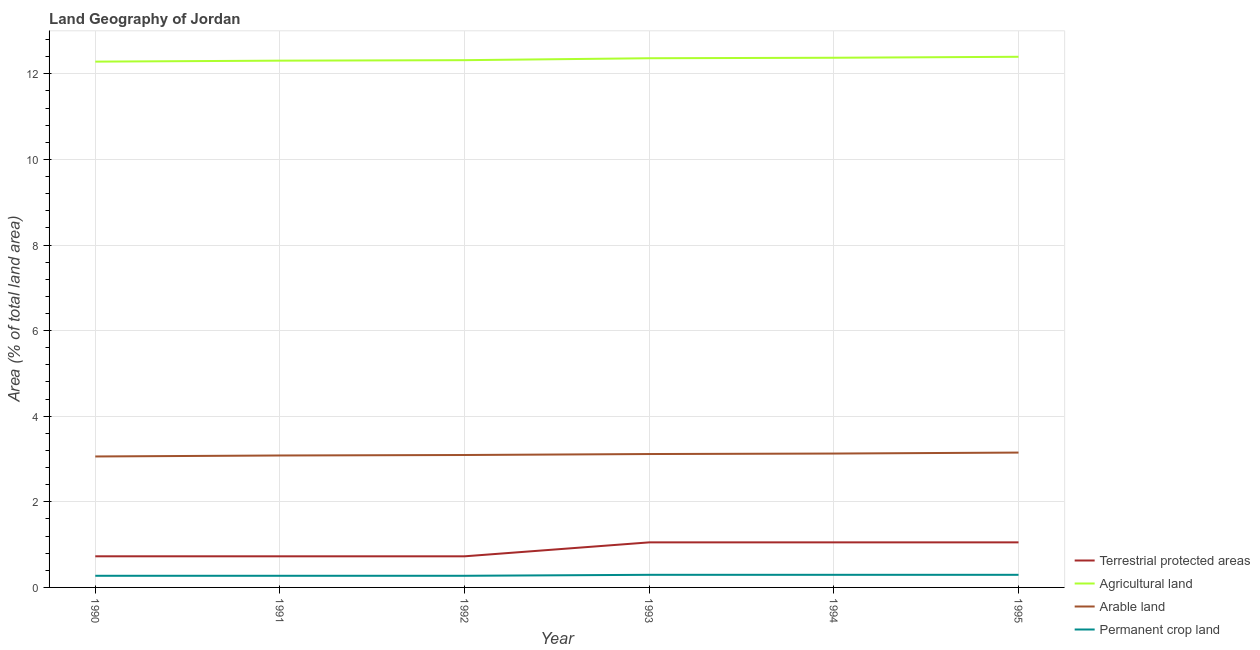What is the percentage of area under agricultural land in 1990?
Your answer should be compact. 12.28. Across all years, what is the maximum percentage of area under agricultural land?
Keep it short and to the point. 12.4. Across all years, what is the minimum percentage of land under terrestrial protection?
Offer a very short reply. 0.73. In which year was the percentage of area under permanent crop land minimum?
Give a very brief answer. 1990. What is the total percentage of area under permanent crop land in the graph?
Give a very brief answer. 1.7. What is the difference between the percentage of area under arable land in 1994 and that in 1995?
Provide a short and direct response. -0.02. What is the difference between the percentage of area under agricultural land in 1992 and the percentage of area under permanent crop land in 1994?
Offer a terse response. 12.02. What is the average percentage of area under agricultural land per year?
Provide a succinct answer. 12.34. In the year 1994, what is the difference between the percentage of area under arable land and percentage of area under permanent crop land?
Offer a very short reply. 2.83. What is the ratio of the percentage of area under arable land in 1994 to that in 1995?
Ensure brevity in your answer.  0.99. Is the difference between the percentage of land under terrestrial protection in 1991 and 1993 greater than the difference between the percentage of area under arable land in 1991 and 1993?
Your answer should be very brief. No. What is the difference between the highest and the second highest percentage of area under permanent crop land?
Provide a succinct answer. 0. What is the difference between the highest and the lowest percentage of area under permanent crop land?
Your answer should be compact. 0.02. In how many years, is the percentage of area under arable land greater than the average percentage of area under arable land taken over all years?
Give a very brief answer. 3. Is it the case that in every year, the sum of the percentage of land under terrestrial protection and percentage of area under permanent crop land is greater than the sum of percentage of area under agricultural land and percentage of area under arable land?
Your response must be concise. No. Is it the case that in every year, the sum of the percentage of land under terrestrial protection and percentage of area under agricultural land is greater than the percentage of area under arable land?
Your answer should be very brief. Yes. Is the percentage of area under agricultural land strictly greater than the percentage of area under permanent crop land over the years?
Your response must be concise. Yes. Is the percentage of area under permanent crop land strictly less than the percentage of area under agricultural land over the years?
Your response must be concise. Yes. How many lines are there?
Your answer should be very brief. 4. How many years are there in the graph?
Provide a short and direct response. 6. What is the difference between two consecutive major ticks on the Y-axis?
Provide a succinct answer. 2. Does the graph contain any zero values?
Your answer should be compact. No. Does the graph contain grids?
Make the answer very short. Yes. How many legend labels are there?
Keep it short and to the point. 4. How are the legend labels stacked?
Make the answer very short. Vertical. What is the title of the graph?
Make the answer very short. Land Geography of Jordan. Does "Quality of public administration" appear as one of the legend labels in the graph?
Your answer should be compact. No. What is the label or title of the Y-axis?
Make the answer very short. Area (% of total land area). What is the Area (% of total land area) in Terrestrial protected areas in 1990?
Keep it short and to the point. 0.73. What is the Area (% of total land area) of Agricultural land in 1990?
Your answer should be compact. 12.28. What is the Area (% of total land area) in Arable land in 1990?
Offer a very short reply. 3.06. What is the Area (% of total land area) of Permanent crop land in 1990?
Offer a very short reply. 0.27. What is the Area (% of total land area) in Terrestrial protected areas in 1991?
Your response must be concise. 0.73. What is the Area (% of total land area) in Agricultural land in 1991?
Make the answer very short. 12.31. What is the Area (% of total land area) of Arable land in 1991?
Offer a very short reply. 3.08. What is the Area (% of total land area) in Permanent crop land in 1991?
Provide a succinct answer. 0.27. What is the Area (% of total land area) in Terrestrial protected areas in 1992?
Provide a succinct answer. 0.73. What is the Area (% of total land area) in Agricultural land in 1992?
Provide a short and direct response. 12.32. What is the Area (% of total land area) in Arable land in 1992?
Your answer should be very brief. 3.09. What is the Area (% of total land area) in Permanent crop land in 1992?
Give a very brief answer. 0.27. What is the Area (% of total land area) of Terrestrial protected areas in 1993?
Offer a very short reply. 1.05. What is the Area (% of total land area) of Agricultural land in 1993?
Keep it short and to the point. 12.36. What is the Area (% of total land area) of Arable land in 1993?
Keep it short and to the point. 3.12. What is the Area (% of total land area) in Permanent crop land in 1993?
Offer a terse response. 0.29. What is the Area (% of total land area) in Terrestrial protected areas in 1994?
Offer a very short reply. 1.05. What is the Area (% of total land area) in Agricultural land in 1994?
Make the answer very short. 12.38. What is the Area (% of total land area) of Arable land in 1994?
Ensure brevity in your answer.  3.13. What is the Area (% of total land area) of Permanent crop land in 1994?
Your response must be concise. 0.29. What is the Area (% of total land area) in Terrestrial protected areas in 1995?
Ensure brevity in your answer.  1.05. What is the Area (% of total land area) of Agricultural land in 1995?
Offer a terse response. 12.4. What is the Area (% of total land area) of Arable land in 1995?
Offer a very short reply. 3.15. What is the Area (% of total land area) of Permanent crop land in 1995?
Offer a very short reply. 0.29. Across all years, what is the maximum Area (% of total land area) in Terrestrial protected areas?
Ensure brevity in your answer.  1.05. Across all years, what is the maximum Area (% of total land area) in Agricultural land?
Offer a very short reply. 12.4. Across all years, what is the maximum Area (% of total land area) in Arable land?
Give a very brief answer. 3.15. Across all years, what is the maximum Area (% of total land area) in Permanent crop land?
Your answer should be very brief. 0.29. Across all years, what is the minimum Area (% of total land area) in Terrestrial protected areas?
Your answer should be compact. 0.73. Across all years, what is the minimum Area (% of total land area) in Agricultural land?
Provide a succinct answer. 12.28. Across all years, what is the minimum Area (% of total land area) in Arable land?
Give a very brief answer. 3.06. Across all years, what is the minimum Area (% of total land area) in Permanent crop land?
Provide a short and direct response. 0.27. What is the total Area (% of total land area) of Terrestrial protected areas in the graph?
Make the answer very short. 5.34. What is the total Area (% of total land area) of Agricultural land in the graph?
Offer a terse response. 74.05. What is the total Area (% of total land area) in Arable land in the graph?
Provide a short and direct response. 18.63. What is the total Area (% of total land area) in Permanent crop land in the graph?
Your response must be concise. 1.7. What is the difference between the Area (% of total land area) of Terrestrial protected areas in 1990 and that in 1991?
Ensure brevity in your answer.  0. What is the difference between the Area (% of total land area) in Agricultural land in 1990 and that in 1991?
Provide a short and direct response. -0.02. What is the difference between the Area (% of total land area) of Arable land in 1990 and that in 1991?
Provide a succinct answer. -0.02. What is the difference between the Area (% of total land area) in Permanent crop land in 1990 and that in 1991?
Your answer should be very brief. 0. What is the difference between the Area (% of total land area) in Terrestrial protected areas in 1990 and that in 1992?
Make the answer very short. 0. What is the difference between the Area (% of total land area) of Agricultural land in 1990 and that in 1992?
Provide a short and direct response. -0.03. What is the difference between the Area (% of total land area) of Arable land in 1990 and that in 1992?
Your answer should be very brief. -0.03. What is the difference between the Area (% of total land area) of Permanent crop land in 1990 and that in 1992?
Offer a very short reply. 0. What is the difference between the Area (% of total land area) in Terrestrial protected areas in 1990 and that in 1993?
Give a very brief answer. -0.33. What is the difference between the Area (% of total land area) of Agricultural land in 1990 and that in 1993?
Provide a succinct answer. -0.08. What is the difference between the Area (% of total land area) in Arable land in 1990 and that in 1993?
Keep it short and to the point. -0.06. What is the difference between the Area (% of total land area) of Permanent crop land in 1990 and that in 1993?
Make the answer very short. -0.02. What is the difference between the Area (% of total land area) in Terrestrial protected areas in 1990 and that in 1994?
Keep it short and to the point. -0.33. What is the difference between the Area (% of total land area) of Agricultural land in 1990 and that in 1994?
Provide a succinct answer. -0.09. What is the difference between the Area (% of total land area) of Arable land in 1990 and that in 1994?
Provide a succinct answer. -0.07. What is the difference between the Area (% of total land area) of Permanent crop land in 1990 and that in 1994?
Your answer should be compact. -0.02. What is the difference between the Area (% of total land area) of Terrestrial protected areas in 1990 and that in 1995?
Give a very brief answer. -0.33. What is the difference between the Area (% of total land area) of Agricultural land in 1990 and that in 1995?
Make the answer very short. -0.11. What is the difference between the Area (% of total land area) in Arable land in 1990 and that in 1995?
Provide a succinct answer. -0.09. What is the difference between the Area (% of total land area) of Permanent crop land in 1990 and that in 1995?
Give a very brief answer. -0.02. What is the difference between the Area (% of total land area) of Terrestrial protected areas in 1991 and that in 1992?
Make the answer very short. 0. What is the difference between the Area (% of total land area) in Agricultural land in 1991 and that in 1992?
Offer a terse response. -0.01. What is the difference between the Area (% of total land area) in Arable land in 1991 and that in 1992?
Make the answer very short. -0.01. What is the difference between the Area (% of total land area) in Terrestrial protected areas in 1991 and that in 1993?
Offer a very short reply. -0.33. What is the difference between the Area (% of total land area) in Agricultural land in 1991 and that in 1993?
Give a very brief answer. -0.06. What is the difference between the Area (% of total land area) of Arable land in 1991 and that in 1993?
Provide a succinct answer. -0.03. What is the difference between the Area (% of total land area) in Permanent crop land in 1991 and that in 1993?
Provide a short and direct response. -0.02. What is the difference between the Area (% of total land area) in Terrestrial protected areas in 1991 and that in 1994?
Make the answer very short. -0.33. What is the difference between the Area (% of total land area) of Agricultural land in 1991 and that in 1994?
Ensure brevity in your answer.  -0.07. What is the difference between the Area (% of total land area) of Arable land in 1991 and that in 1994?
Ensure brevity in your answer.  -0.05. What is the difference between the Area (% of total land area) of Permanent crop land in 1991 and that in 1994?
Keep it short and to the point. -0.02. What is the difference between the Area (% of total land area) in Terrestrial protected areas in 1991 and that in 1995?
Your response must be concise. -0.33. What is the difference between the Area (% of total land area) of Agricultural land in 1991 and that in 1995?
Ensure brevity in your answer.  -0.09. What is the difference between the Area (% of total land area) of Arable land in 1991 and that in 1995?
Your answer should be compact. -0.07. What is the difference between the Area (% of total land area) of Permanent crop land in 1991 and that in 1995?
Give a very brief answer. -0.02. What is the difference between the Area (% of total land area) of Terrestrial protected areas in 1992 and that in 1993?
Offer a very short reply. -0.33. What is the difference between the Area (% of total land area) in Agricultural land in 1992 and that in 1993?
Ensure brevity in your answer.  -0.05. What is the difference between the Area (% of total land area) in Arable land in 1992 and that in 1993?
Your response must be concise. -0.02. What is the difference between the Area (% of total land area) of Permanent crop land in 1992 and that in 1993?
Your response must be concise. -0.02. What is the difference between the Area (% of total land area) of Terrestrial protected areas in 1992 and that in 1994?
Offer a terse response. -0.33. What is the difference between the Area (% of total land area) of Agricultural land in 1992 and that in 1994?
Offer a very short reply. -0.06. What is the difference between the Area (% of total land area) in Arable land in 1992 and that in 1994?
Offer a very short reply. -0.03. What is the difference between the Area (% of total land area) in Permanent crop land in 1992 and that in 1994?
Your answer should be compact. -0.02. What is the difference between the Area (% of total land area) in Terrestrial protected areas in 1992 and that in 1995?
Your response must be concise. -0.33. What is the difference between the Area (% of total land area) of Agricultural land in 1992 and that in 1995?
Keep it short and to the point. -0.08. What is the difference between the Area (% of total land area) in Arable land in 1992 and that in 1995?
Provide a short and direct response. -0.06. What is the difference between the Area (% of total land area) in Permanent crop land in 1992 and that in 1995?
Offer a terse response. -0.02. What is the difference between the Area (% of total land area) in Agricultural land in 1993 and that in 1994?
Your response must be concise. -0.01. What is the difference between the Area (% of total land area) of Arable land in 1993 and that in 1994?
Your answer should be compact. -0.01. What is the difference between the Area (% of total land area) in Permanent crop land in 1993 and that in 1994?
Offer a very short reply. 0. What is the difference between the Area (% of total land area) in Terrestrial protected areas in 1993 and that in 1995?
Keep it short and to the point. 0. What is the difference between the Area (% of total land area) of Agricultural land in 1993 and that in 1995?
Your response must be concise. -0.03. What is the difference between the Area (% of total land area) of Arable land in 1993 and that in 1995?
Your answer should be compact. -0.03. What is the difference between the Area (% of total land area) in Permanent crop land in 1993 and that in 1995?
Give a very brief answer. 0. What is the difference between the Area (% of total land area) of Terrestrial protected areas in 1994 and that in 1995?
Ensure brevity in your answer.  0. What is the difference between the Area (% of total land area) in Agricultural land in 1994 and that in 1995?
Offer a terse response. -0.02. What is the difference between the Area (% of total land area) in Arable land in 1994 and that in 1995?
Your response must be concise. -0.02. What is the difference between the Area (% of total land area) of Permanent crop land in 1994 and that in 1995?
Provide a succinct answer. 0. What is the difference between the Area (% of total land area) in Terrestrial protected areas in 1990 and the Area (% of total land area) in Agricultural land in 1991?
Your answer should be compact. -11.58. What is the difference between the Area (% of total land area) of Terrestrial protected areas in 1990 and the Area (% of total land area) of Arable land in 1991?
Your answer should be very brief. -2.36. What is the difference between the Area (% of total land area) in Terrestrial protected areas in 1990 and the Area (% of total land area) in Permanent crop land in 1991?
Ensure brevity in your answer.  0.46. What is the difference between the Area (% of total land area) of Agricultural land in 1990 and the Area (% of total land area) of Arable land in 1991?
Keep it short and to the point. 9.2. What is the difference between the Area (% of total land area) of Agricultural land in 1990 and the Area (% of total land area) of Permanent crop land in 1991?
Give a very brief answer. 12.01. What is the difference between the Area (% of total land area) of Arable land in 1990 and the Area (% of total land area) of Permanent crop land in 1991?
Your response must be concise. 2.79. What is the difference between the Area (% of total land area) in Terrestrial protected areas in 1990 and the Area (% of total land area) in Agricultural land in 1992?
Provide a succinct answer. -11.59. What is the difference between the Area (% of total land area) of Terrestrial protected areas in 1990 and the Area (% of total land area) of Arable land in 1992?
Ensure brevity in your answer.  -2.37. What is the difference between the Area (% of total land area) of Terrestrial protected areas in 1990 and the Area (% of total land area) of Permanent crop land in 1992?
Ensure brevity in your answer.  0.46. What is the difference between the Area (% of total land area) in Agricultural land in 1990 and the Area (% of total land area) in Arable land in 1992?
Keep it short and to the point. 9.19. What is the difference between the Area (% of total land area) in Agricultural land in 1990 and the Area (% of total land area) in Permanent crop land in 1992?
Provide a short and direct response. 12.01. What is the difference between the Area (% of total land area) of Arable land in 1990 and the Area (% of total land area) of Permanent crop land in 1992?
Ensure brevity in your answer.  2.79. What is the difference between the Area (% of total land area) of Terrestrial protected areas in 1990 and the Area (% of total land area) of Agricultural land in 1993?
Give a very brief answer. -11.64. What is the difference between the Area (% of total land area) of Terrestrial protected areas in 1990 and the Area (% of total land area) of Arable land in 1993?
Offer a terse response. -2.39. What is the difference between the Area (% of total land area) of Terrestrial protected areas in 1990 and the Area (% of total land area) of Permanent crop land in 1993?
Your response must be concise. 0.43. What is the difference between the Area (% of total land area) of Agricultural land in 1990 and the Area (% of total land area) of Arable land in 1993?
Keep it short and to the point. 9.17. What is the difference between the Area (% of total land area) of Agricultural land in 1990 and the Area (% of total land area) of Permanent crop land in 1993?
Offer a very short reply. 11.99. What is the difference between the Area (% of total land area) of Arable land in 1990 and the Area (% of total land area) of Permanent crop land in 1993?
Your response must be concise. 2.77. What is the difference between the Area (% of total land area) of Terrestrial protected areas in 1990 and the Area (% of total land area) of Agricultural land in 1994?
Keep it short and to the point. -11.65. What is the difference between the Area (% of total land area) in Terrestrial protected areas in 1990 and the Area (% of total land area) in Arable land in 1994?
Your response must be concise. -2.4. What is the difference between the Area (% of total land area) of Terrestrial protected areas in 1990 and the Area (% of total land area) of Permanent crop land in 1994?
Provide a succinct answer. 0.43. What is the difference between the Area (% of total land area) in Agricultural land in 1990 and the Area (% of total land area) in Arable land in 1994?
Provide a succinct answer. 9.16. What is the difference between the Area (% of total land area) in Agricultural land in 1990 and the Area (% of total land area) in Permanent crop land in 1994?
Make the answer very short. 11.99. What is the difference between the Area (% of total land area) of Arable land in 1990 and the Area (% of total land area) of Permanent crop land in 1994?
Your response must be concise. 2.77. What is the difference between the Area (% of total land area) in Terrestrial protected areas in 1990 and the Area (% of total land area) in Agricultural land in 1995?
Offer a very short reply. -11.67. What is the difference between the Area (% of total land area) of Terrestrial protected areas in 1990 and the Area (% of total land area) of Arable land in 1995?
Offer a very short reply. -2.42. What is the difference between the Area (% of total land area) of Terrestrial protected areas in 1990 and the Area (% of total land area) of Permanent crop land in 1995?
Make the answer very short. 0.43. What is the difference between the Area (% of total land area) of Agricultural land in 1990 and the Area (% of total land area) of Arable land in 1995?
Provide a succinct answer. 9.13. What is the difference between the Area (% of total land area) in Agricultural land in 1990 and the Area (% of total land area) in Permanent crop land in 1995?
Ensure brevity in your answer.  11.99. What is the difference between the Area (% of total land area) of Arable land in 1990 and the Area (% of total land area) of Permanent crop land in 1995?
Provide a short and direct response. 2.77. What is the difference between the Area (% of total land area) of Terrestrial protected areas in 1991 and the Area (% of total land area) of Agricultural land in 1992?
Your response must be concise. -11.59. What is the difference between the Area (% of total land area) in Terrestrial protected areas in 1991 and the Area (% of total land area) in Arable land in 1992?
Offer a terse response. -2.37. What is the difference between the Area (% of total land area) in Terrestrial protected areas in 1991 and the Area (% of total land area) in Permanent crop land in 1992?
Provide a succinct answer. 0.45. What is the difference between the Area (% of total land area) of Agricultural land in 1991 and the Area (% of total land area) of Arable land in 1992?
Offer a very short reply. 9.21. What is the difference between the Area (% of total land area) in Agricultural land in 1991 and the Area (% of total land area) in Permanent crop land in 1992?
Provide a short and direct response. 12.04. What is the difference between the Area (% of total land area) of Arable land in 1991 and the Area (% of total land area) of Permanent crop land in 1992?
Your answer should be very brief. 2.81. What is the difference between the Area (% of total land area) in Terrestrial protected areas in 1991 and the Area (% of total land area) in Agricultural land in 1993?
Your response must be concise. -11.64. What is the difference between the Area (% of total land area) of Terrestrial protected areas in 1991 and the Area (% of total land area) of Arable land in 1993?
Provide a succinct answer. -2.39. What is the difference between the Area (% of total land area) of Terrestrial protected areas in 1991 and the Area (% of total land area) of Permanent crop land in 1993?
Your response must be concise. 0.43. What is the difference between the Area (% of total land area) of Agricultural land in 1991 and the Area (% of total land area) of Arable land in 1993?
Ensure brevity in your answer.  9.19. What is the difference between the Area (% of total land area) in Agricultural land in 1991 and the Area (% of total land area) in Permanent crop land in 1993?
Ensure brevity in your answer.  12.01. What is the difference between the Area (% of total land area) in Arable land in 1991 and the Area (% of total land area) in Permanent crop land in 1993?
Make the answer very short. 2.79. What is the difference between the Area (% of total land area) of Terrestrial protected areas in 1991 and the Area (% of total land area) of Agricultural land in 1994?
Keep it short and to the point. -11.65. What is the difference between the Area (% of total land area) in Terrestrial protected areas in 1991 and the Area (% of total land area) in Arable land in 1994?
Provide a short and direct response. -2.4. What is the difference between the Area (% of total land area) in Terrestrial protected areas in 1991 and the Area (% of total land area) in Permanent crop land in 1994?
Keep it short and to the point. 0.43. What is the difference between the Area (% of total land area) of Agricultural land in 1991 and the Area (% of total land area) of Arable land in 1994?
Your answer should be very brief. 9.18. What is the difference between the Area (% of total land area) in Agricultural land in 1991 and the Area (% of total land area) in Permanent crop land in 1994?
Your answer should be compact. 12.01. What is the difference between the Area (% of total land area) in Arable land in 1991 and the Area (% of total land area) in Permanent crop land in 1994?
Keep it short and to the point. 2.79. What is the difference between the Area (% of total land area) in Terrestrial protected areas in 1991 and the Area (% of total land area) in Agricultural land in 1995?
Your answer should be compact. -11.67. What is the difference between the Area (% of total land area) of Terrestrial protected areas in 1991 and the Area (% of total land area) of Arable land in 1995?
Provide a short and direct response. -2.42. What is the difference between the Area (% of total land area) in Terrestrial protected areas in 1991 and the Area (% of total land area) in Permanent crop land in 1995?
Provide a succinct answer. 0.43. What is the difference between the Area (% of total land area) in Agricultural land in 1991 and the Area (% of total land area) in Arable land in 1995?
Make the answer very short. 9.16. What is the difference between the Area (% of total land area) of Agricultural land in 1991 and the Area (% of total land area) of Permanent crop land in 1995?
Offer a terse response. 12.01. What is the difference between the Area (% of total land area) in Arable land in 1991 and the Area (% of total land area) in Permanent crop land in 1995?
Your answer should be compact. 2.79. What is the difference between the Area (% of total land area) in Terrestrial protected areas in 1992 and the Area (% of total land area) in Agricultural land in 1993?
Keep it short and to the point. -11.64. What is the difference between the Area (% of total land area) of Terrestrial protected areas in 1992 and the Area (% of total land area) of Arable land in 1993?
Offer a terse response. -2.39. What is the difference between the Area (% of total land area) in Terrestrial protected areas in 1992 and the Area (% of total land area) in Permanent crop land in 1993?
Ensure brevity in your answer.  0.43. What is the difference between the Area (% of total land area) of Agricultural land in 1992 and the Area (% of total land area) of Arable land in 1993?
Offer a very short reply. 9.2. What is the difference between the Area (% of total land area) in Agricultural land in 1992 and the Area (% of total land area) in Permanent crop land in 1993?
Ensure brevity in your answer.  12.02. What is the difference between the Area (% of total land area) of Arable land in 1992 and the Area (% of total land area) of Permanent crop land in 1993?
Your response must be concise. 2.8. What is the difference between the Area (% of total land area) in Terrestrial protected areas in 1992 and the Area (% of total land area) in Agricultural land in 1994?
Your answer should be very brief. -11.65. What is the difference between the Area (% of total land area) of Terrestrial protected areas in 1992 and the Area (% of total land area) of Arable land in 1994?
Provide a succinct answer. -2.4. What is the difference between the Area (% of total land area) of Terrestrial protected areas in 1992 and the Area (% of total land area) of Permanent crop land in 1994?
Your answer should be compact. 0.43. What is the difference between the Area (% of total land area) in Agricultural land in 1992 and the Area (% of total land area) in Arable land in 1994?
Offer a terse response. 9.19. What is the difference between the Area (% of total land area) in Agricultural land in 1992 and the Area (% of total land area) in Permanent crop land in 1994?
Your answer should be compact. 12.02. What is the difference between the Area (% of total land area) of Arable land in 1992 and the Area (% of total land area) of Permanent crop land in 1994?
Ensure brevity in your answer.  2.8. What is the difference between the Area (% of total land area) of Terrestrial protected areas in 1992 and the Area (% of total land area) of Agricultural land in 1995?
Your answer should be compact. -11.67. What is the difference between the Area (% of total land area) of Terrestrial protected areas in 1992 and the Area (% of total land area) of Arable land in 1995?
Give a very brief answer. -2.42. What is the difference between the Area (% of total land area) of Terrestrial protected areas in 1992 and the Area (% of total land area) of Permanent crop land in 1995?
Your answer should be very brief. 0.43. What is the difference between the Area (% of total land area) of Agricultural land in 1992 and the Area (% of total land area) of Arable land in 1995?
Your answer should be compact. 9.17. What is the difference between the Area (% of total land area) of Agricultural land in 1992 and the Area (% of total land area) of Permanent crop land in 1995?
Offer a very short reply. 12.02. What is the difference between the Area (% of total land area) in Arable land in 1992 and the Area (% of total land area) in Permanent crop land in 1995?
Offer a very short reply. 2.8. What is the difference between the Area (% of total land area) of Terrestrial protected areas in 1993 and the Area (% of total land area) of Agricultural land in 1994?
Make the answer very short. -11.32. What is the difference between the Area (% of total land area) of Terrestrial protected areas in 1993 and the Area (% of total land area) of Arable land in 1994?
Offer a terse response. -2.08. What is the difference between the Area (% of total land area) of Terrestrial protected areas in 1993 and the Area (% of total land area) of Permanent crop land in 1994?
Give a very brief answer. 0.76. What is the difference between the Area (% of total land area) of Agricultural land in 1993 and the Area (% of total land area) of Arable land in 1994?
Keep it short and to the point. 9.24. What is the difference between the Area (% of total land area) in Agricultural land in 1993 and the Area (% of total land area) in Permanent crop land in 1994?
Provide a short and direct response. 12.07. What is the difference between the Area (% of total land area) in Arable land in 1993 and the Area (% of total land area) in Permanent crop land in 1994?
Keep it short and to the point. 2.82. What is the difference between the Area (% of total land area) in Terrestrial protected areas in 1993 and the Area (% of total land area) in Agricultural land in 1995?
Make the answer very short. -11.35. What is the difference between the Area (% of total land area) in Terrestrial protected areas in 1993 and the Area (% of total land area) in Arable land in 1995?
Offer a terse response. -2.1. What is the difference between the Area (% of total land area) of Terrestrial protected areas in 1993 and the Area (% of total land area) of Permanent crop land in 1995?
Your answer should be compact. 0.76. What is the difference between the Area (% of total land area) in Agricultural land in 1993 and the Area (% of total land area) in Arable land in 1995?
Offer a very short reply. 9.21. What is the difference between the Area (% of total land area) in Agricultural land in 1993 and the Area (% of total land area) in Permanent crop land in 1995?
Offer a terse response. 12.07. What is the difference between the Area (% of total land area) in Arable land in 1993 and the Area (% of total land area) in Permanent crop land in 1995?
Make the answer very short. 2.82. What is the difference between the Area (% of total land area) of Terrestrial protected areas in 1994 and the Area (% of total land area) of Agricultural land in 1995?
Provide a succinct answer. -11.35. What is the difference between the Area (% of total land area) of Terrestrial protected areas in 1994 and the Area (% of total land area) of Arable land in 1995?
Offer a very short reply. -2.1. What is the difference between the Area (% of total land area) in Terrestrial protected areas in 1994 and the Area (% of total land area) in Permanent crop land in 1995?
Ensure brevity in your answer.  0.76. What is the difference between the Area (% of total land area) of Agricultural land in 1994 and the Area (% of total land area) of Arable land in 1995?
Offer a terse response. 9.22. What is the difference between the Area (% of total land area) in Agricultural land in 1994 and the Area (% of total land area) in Permanent crop land in 1995?
Your response must be concise. 12.08. What is the difference between the Area (% of total land area) of Arable land in 1994 and the Area (% of total land area) of Permanent crop land in 1995?
Your response must be concise. 2.83. What is the average Area (% of total land area) in Terrestrial protected areas per year?
Keep it short and to the point. 0.89. What is the average Area (% of total land area) in Agricultural land per year?
Your answer should be compact. 12.34. What is the average Area (% of total land area) in Arable land per year?
Provide a short and direct response. 3.11. What is the average Area (% of total land area) in Permanent crop land per year?
Your answer should be compact. 0.28. In the year 1990, what is the difference between the Area (% of total land area) in Terrestrial protected areas and Area (% of total land area) in Agricultural land?
Make the answer very short. -11.56. In the year 1990, what is the difference between the Area (% of total land area) of Terrestrial protected areas and Area (% of total land area) of Arable land?
Your answer should be very brief. -2.33. In the year 1990, what is the difference between the Area (% of total land area) in Terrestrial protected areas and Area (% of total land area) in Permanent crop land?
Keep it short and to the point. 0.46. In the year 1990, what is the difference between the Area (% of total land area) in Agricultural land and Area (% of total land area) in Arable land?
Give a very brief answer. 9.22. In the year 1990, what is the difference between the Area (% of total land area) of Agricultural land and Area (% of total land area) of Permanent crop land?
Offer a terse response. 12.01. In the year 1990, what is the difference between the Area (% of total land area) of Arable land and Area (% of total land area) of Permanent crop land?
Your answer should be very brief. 2.79. In the year 1991, what is the difference between the Area (% of total land area) of Terrestrial protected areas and Area (% of total land area) of Agricultural land?
Provide a succinct answer. -11.58. In the year 1991, what is the difference between the Area (% of total land area) of Terrestrial protected areas and Area (% of total land area) of Arable land?
Offer a terse response. -2.36. In the year 1991, what is the difference between the Area (% of total land area) of Terrestrial protected areas and Area (% of total land area) of Permanent crop land?
Make the answer very short. 0.45. In the year 1991, what is the difference between the Area (% of total land area) of Agricultural land and Area (% of total land area) of Arable land?
Provide a short and direct response. 9.22. In the year 1991, what is the difference between the Area (% of total land area) in Agricultural land and Area (% of total land area) in Permanent crop land?
Offer a very short reply. 12.04. In the year 1991, what is the difference between the Area (% of total land area) of Arable land and Area (% of total land area) of Permanent crop land?
Provide a short and direct response. 2.81. In the year 1992, what is the difference between the Area (% of total land area) in Terrestrial protected areas and Area (% of total land area) in Agricultural land?
Offer a terse response. -11.59. In the year 1992, what is the difference between the Area (% of total land area) of Terrestrial protected areas and Area (% of total land area) of Arable land?
Your response must be concise. -2.37. In the year 1992, what is the difference between the Area (% of total land area) in Terrestrial protected areas and Area (% of total land area) in Permanent crop land?
Provide a short and direct response. 0.45. In the year 1992, what is the difference between the Area (% of total land area) in Agricultural land and Area (% of total land area) in Arable land?
Your response must be concise. 9.22. In the year 1992, what is the difference between the Area (% of total land area) of Agricultural land and Area (% of total land area) of Permanent crop land?
Your answer should be very brief. 12.05. In the year 1992, what is the difference between the Area (% of total land area) in Arable land and Area (% of total land area) in Permanent crop land?
Your answer should be very brief. 2.82. In the year 1993, what is the difference between the Area (% of total land area) of Terrestrial protected areas and Area (% of total land area) of Agricultural land?
Keep it short and to the point. -11.31. In the year 1993, what is the difference between the Area (% of total land area) in Terrestrial protected areas and Area (% of total land area) in Arable land?
Make the answer very short. -2.06. In the year 1993, what is the difference between the Area (% of total land area) of Terrestrial protected areas and Area (% of total land area) of Permanent crop land?
Provide a succinct answer. 0.76. In the year 1993, what is the difference between the Area (% of total land area) in Agricultural land and Area (% of total land area) in Arable land?
Your response must be concise. 9.25. In the year 1993, what is the difference between the Area (% of total land area) in Agricultural land and Area (% of total land area) in Permanent crop land?
Offer a terse response. 12.07. In the year 1993, what is the difference between the Area (% of total land area) in Arable land and Area (% of total land area) in Permanent crop land?
Your response must be concise. 2.82. In the year 1994, what is the difference between the Area (% of total land area) in Terrestrial protected areas and Area (% of total land area) in Agricultural land?
Ensure brevity in your answer.  -11.32. In the year 1994, what is the difference between the Area (% of total land area) of Terrestrial protected areas and Area (% of total land area) of Arable land?
Keep it short and to the point. -2.08. In the year 1994, what is the difference between the Area (% of total land area) in Terrestrial protected areas and Area (% of total land area) in Permanent crop land?
Give a very brief answer. 0.76. In the year 1994, what is the difference between the Area (% of total land area) of Agricultural land and Area (% of total land area) of Arable land?
Provide a short and direct response. 9.25. In the year 1994, what is the difference between the Area (% of total land area) of Agricultural land and Area (% of total land area) of Permanent crop land?
Offer a very short reply. 12.08. In the year 1994, what is the difference between the Area (% of total land area) of Arable land and Area (% of total land area) of Permanent crop land?
Your response must be concise. 2.83. In the year 1995, what is the difference between the Area (% of total land area) of Terrestrial protected areas and Area (% of total land area) of Agricultural land?
Give a very brief answer. -11.35. In the year 1995, what is the difference between the Area (% of total land area) of Terrestrial protected areas and Area (% of total land area) of Arable land?
Give a very brief answer. -2.1. In the year 1995, what is the difference between the Area (% of total land area) in Terrestrial protected areas and Area (% of total land area) in Permanent crop land?
Provide a short and direct response. 0.76. In the year 1995, what is the difference between the Area (% of total land area) in Agricultural land and Area (% of total land area) in Arable land?
Keep it short and to the point. 9.25. In the year 1995, what is the difference between the Area (% of total land area) of Agricultural land and Area (% of total land area) of Permanent crop land?
Provide a succinct answer. 12.1. In the year 1995, what is the difference between the Area (% of total land area) in Arable land and Area (% of total land area) in Permanent crop land?
Offer a terse response. 2.86. What is the ratio of the Area (% of total land area) in Terrestrial protected areas in 1990 to that in 1991?
Keep it short and to the point. 1. What is the ratio of the Area (% of total land area) in Agricultural land in 1990 to that in 1991?
Ensure brevity in your answer.  1. What is the ratio of the Area (% of total land area) in Arable land in 1990 to that in 1991?
Your response must be concise. 0.99. What is the ratio of the Area (% of total land area) of Agricultural land in 1990 to that in 1992?
Your answer should be very brief. 1. What is the ratio of the Area (% of total land area) in Permanent crop land in 1990 to that in 1992?
Keep it short and to the point. 1. What is the ratio of the Area (% of total land area) of Terrestrial protected areas in 1990 to that in 1993?
Your answer should be very brief. 0.69. What is the ratio of the Area (% of total land area) of Agricultural land in 1990 to that in 1993?
Offer a very short reply. 0.99. What is the ratio of the Area (% of total land area) of Arable land in 1990 to that in 1993?
Your answer should be very brief. 0.98. What is the ratio of the Area (% of total land area) of Permanent crop land in 1990 to that in 1993?
Keep it short and to the point. 0.92. What is the ratio of the Area (% of total land area) in Terrestrial protected areas in 1990 to that in 1994?
Your response must be concise. 0.69. What is the ratio of the Area (% of total land area) of Agricultural land in 1990 to that in 1994?
Provide a succinct answer. 0.99. What is the ratio of the Area (% of total land area) of Arable land in 1990 to that in 1994?
Your answer should be very brief. 0.98. What is the ratio of the Area (% of total land area) in Terrestrial protected areas in 1990 to that in 1995?
Make the answer very short. 0.69. What is the ratio of the Area (% of total land area) in Agricultural land in 1990 to that in 1995?
Offer a terse response. 0.99. What is the ratio of the Area (% of total land area) in Arable land in 1990 to that in 1995?
Offer a terse response. 0.97. What is the ratio of the Area (% of total land area) in Terrestrial protected areas in 1991 to that in 1992?
Ensure brevity in your answer.  1. What is the ratio of the Area (% of total land area) of Arable land in 1991 to that in 1992?
Provide a short and direct response. 1. What is the ratio of the Area (% of total land area) of Terrestrial protected areas in 1991 to that in 1993?
Keep it short and to the point. 0.69. What is the ratio of the Area (% of total land area) in Terrestrial protected areas in 1991 to that in 1994?
Ensure brevity in your answer.  0.69. What is the ratio of the Area (% of total land area) in Agricultural land in 1991 to that in 1994?
Give a very brief answer. 0.99. What is the ratio of the Area (% of total land area) in Arable land in 1991 to that in 1994?
Your answer should be compact. 0.99. What is the ratio of the Area (% of total land area) in Permanent crop land in 1991 to that in 1994?
Your response must be concise. 0.92. What is the ratio of the Area (% of total land area) of Terrestrial protected areas in 1991 to that in 1995?
Your answer should be compact. 0.69. What is the ratio of the Area (% of total land area) in Arable land in 1991 to that in 1995?
Ensure brevity in your answer.  0.98. What is the ratio of the Area (% of total land area) in Permanent crop land in 1991 to that in 1995?
Give a very brief answer. 0.92. What is the ratio of the Area (% of total land area) in Terrestrial protected areas in 1992 to that in 1993?
Offer a terse response. 0.69. What is the ratio of the Area (% of total land area) in Agricultural land in 1992 to that in 1993?
Provide a short and direct response. 1. What is the ratio of the Area (% of total land area) in Arable land in 1992 to that in 1993?
Your response must be concise. 0.99. What is the ratio of the Area (% of total land area) in Terrestrial protected areas in 1992 to that in 1994?
Keep it short and to the point. 0.69. What is the ratio of the Area (% of total land area) in Agricultural land in 1992 to that in 1994?
Provide a short and direct response. 1. What is the ratio of the Area (% of total land area) of Arable land in 1992 to that in 1994?
Your answer should be compact. 0.99. What is the ratio of the Area (% of total land area) in Permanent crop land in 1992 to that in 1994?
Make the answer very short. 0.92. What is the ratio of the Area (% of total land area) of Terrestrial protected areas in 1992 to that in 1995?
Offer a very short reply. 0.69. What is the ratio of the Area (% of total land area) in Agricultural land in 1992 to that in 1995?
Your answer should be compact. 0.99. What is the ratio of the Area (% of total land area) of Permanent crop land in 1992 to that in 1995?
Provide a short and direct response. 0.92. What is the ratio of the Area (% of total land area) in Terrestrial protected areas in 1993 to that in 1994?
Your answer should be compact. 1. What is the ratio of the Area (% of total land area) of Agricultural land in 1993 to that in 1994?
Give a very brief answer. 1. What is the ratio of the Area (% of total land area) of Permanent crop land in 1993 to that in 1994?
Offer a very short reply. 1. What is the ratio of the Area (% of total land area) in Arable land in 1993 to that in 1995?
Give a very brief answer. 0.99. What is the ratio of the Area (% of total land area) of Permanent crop land in 1993 to that in 1995?
Your answer should be very brief. 1. What is the ratio of the Area (% of total land area) of Terrestrial protected areas in 1994 to that in 1995?
Keep it short and to the point. 1. What is the ratio of the Area (% of total land area) of Agricultural land in 1994 to that in 1995?
Give a very brief answer. 1. What is the ratio of the Area (% of total land area) in Arable land in 1994 to that in 1995?
Your answer should be compact. 0.99. What is the difference between the highest and the second highest Area (% of total land area) in Terrestrial protected areas?
Ensure brevity in your answer.  0. What is the difference between the highest and the second highest Area (% of total land area) in Agricultural land?
Provide a succinct answer. 0.02. What is the difference between the highest and the second highest Area (% of total land area) in Arable land?
Your response must be concise. 0.02. What is the difference between the highest and the second highest Area (% of total land area) in Permanent crop land?
Provide a short and direct response. 0. What is the difference between the highest and the lowest Area (% of total land area) of Terrestrial protected areas?
Offer a very short reply. 0.33. What is the difference between the highest and the lowest Area (% of total land area) in Agricultural land?
Your answer should be compact. 0.11. What is the difference between the highest and the lowest Area (% of total land area) of Arable land?
Make the answer very short. 0.09. What is the difference between the highest and the lowest Area (% of total land area) in Permanent crop land?
Keep it short and to the point. 0.02. 